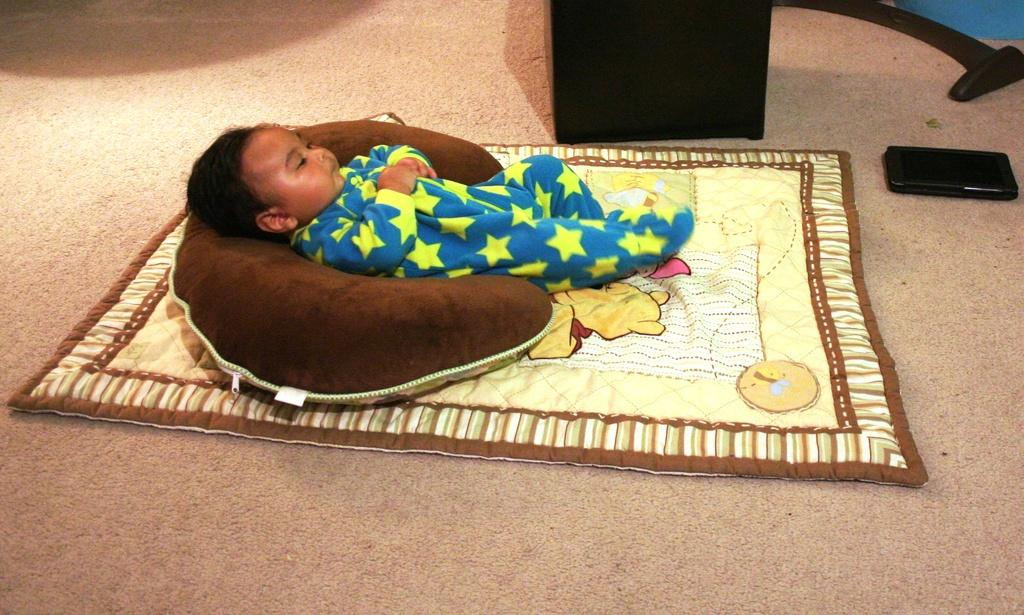What is the main subject of the image? There is a baby lying on the bed. Can you describe the baby's position or activity? The baby is lying on the bed. What else can be seen in the image? There is a device on the floor on the right side. Is the baby's father present in the image? There is no information about the baby's father in the image. Is it raining in the image? There is no indication of rain in the image. 